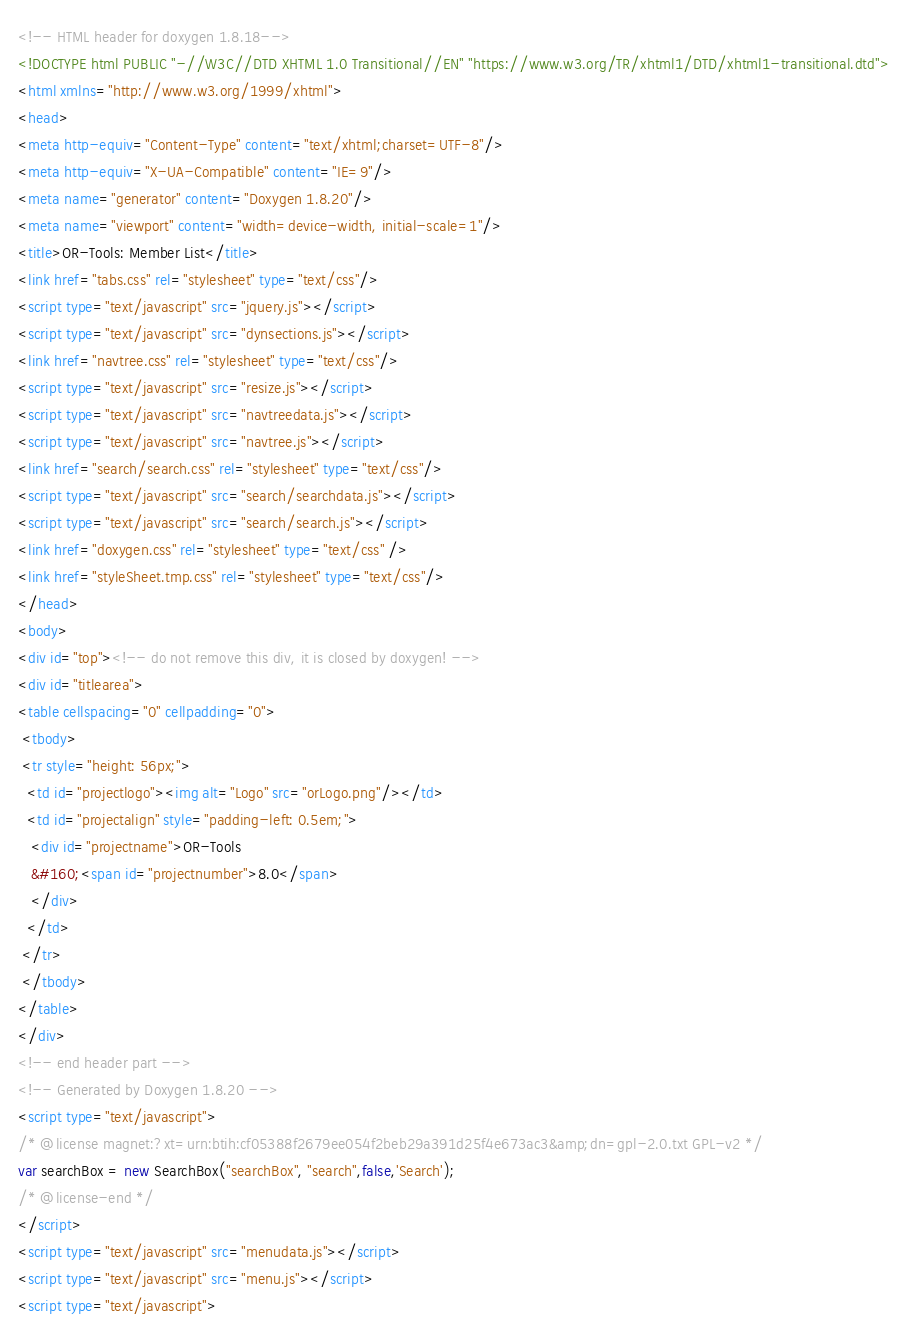<code> <loc_0><loc_0><loc_500><loc_500><_HTML_><!-- HTML header for doxygen 1.8.18-->
<!DOCTYPE html PUBLIC "-//W3C//DTD XHTML 1.0 Transitional//EN" "https://www.w3.org/TR/xhtml1/DTD/xhtml1-transitional.dtd">
<html xmlns="http://www.w3.org/1999/xhtml">
<head>
<meta http-equiv="Content-Type" content="text/xhtml;charset=UTF-8"/>
<meta http-equiv="X-UA-Compatible" content="IE=9"/>
<meta name="generator" content="Doxygen 1.8.20"/>
<meta name="viewport" content="width=device-width, initial-scale=1"/>
<title>OR-Tools: Member List</title>
<link href="tabs.css" rel="stylesheet" type="text/css"/>
<script type="text/javascript" src="jquery.js"></script>
<script type="text/javascript" src="dynsections.js"></script>
<link href="navtree.css" rel="stylesheet" type="text/css"/>
<script type="text/javascript" src="resize.js"></script>
<script type="text/javascript" src="navtreedata.js"></script>
<script type="text/javascript" src="navtree.js"></script>
<link href="search/search.css" rel="stylesheet" type="text/css"/>
<script type="text/javascript" src="search/searchdata.js"></script>
<script type="text/javascript" src="search/search.js"></script>
<link href="doxygen.css" rel="stylesheet" type="text/css" />
<link href="styleSheet.tmp.css" rel="stylesheet" type="text/css"/>
</head>
<body>
<div id="top"><!-- do not remove this div, it is closed by doxygen! -->
<div id="titlearea">
<table cellspacing="0" cellpadding="0">
 <tbody>
 <tr style="height: 56px;">
  <td id="projectlogo"><img alt="Logo" src="orLogo.png"/></td>
  <td id="projectalign" style="padding-left: 0.5em;">
   <div id="projectname">OR-Tools
   &#160;<span id="projectnumber">8.0</span>
   </div>
  </td>
 </tr>
 </tbody>
</table>
</div>
<!-- end header part -->
<!-- Generated by Doxygen 1.8.20 -->
<script type="text/javascript">
/* @license magnet:?xt=urn:btih:cf05388f2679ee054f2beb29a391d25f4e673ac3&amp;dn=gpl-2.0.txt GPL-v2 */
var searchBox = new SearchBox("searchBox", "search",false,'Search');
/* @license-end */
</script>
<script type="text/javascript" src="menudata.js"></script>
<script type="text/javascript" src="menu.js"></script>
<script type="text/javascript"></code> 